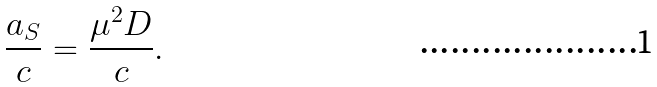Convert formula to latex. <formula><loc_0><loc_0><loc_500><loc_500>\frac { a _ { S } } { c } = \frac { \mu ^ { 2 } D } { c } .</formula> 